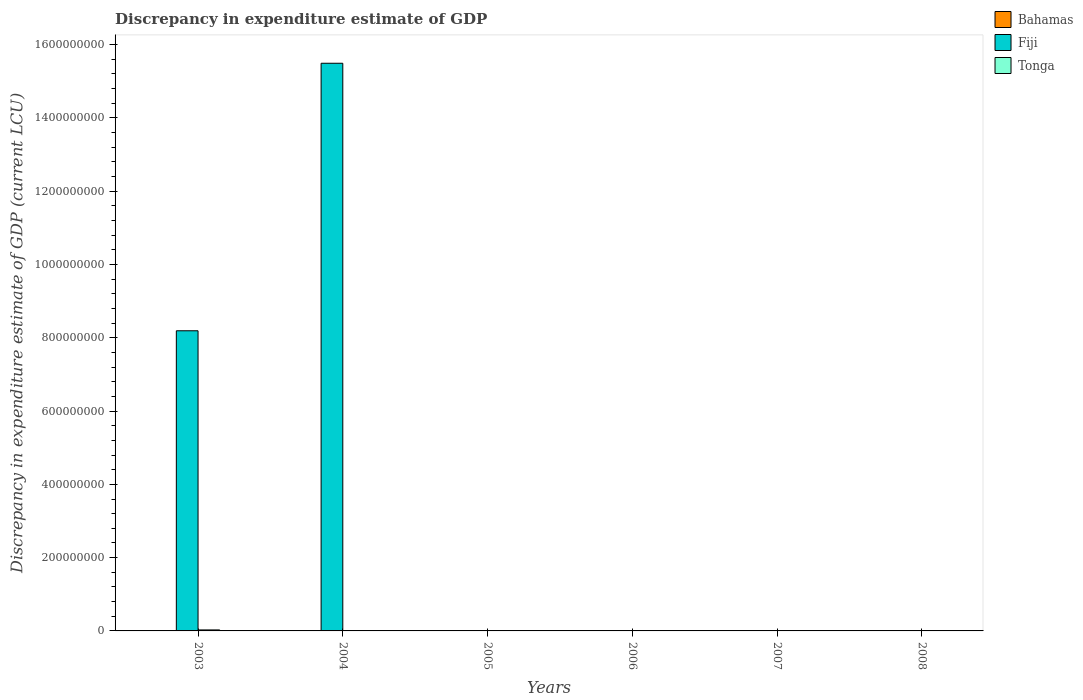How many different coloured bars are there?
Your answer should be very brief. 3. Are the number of bars on each tick of the X-axis equal?
Offer a very short reply. No. How many bars are there on the 2nd tick from the left?
Keep it short and to the point. 2. How many bars are there on the 4th tick from the right?
Your response must be concise. 1. What is the label of the 4th group of bars from the left?
Ensure brevity in your answer.  2006. In how many cases, is the number of bars for a given year not equal to the number of legend labels?
Offer a terse response. 5. What is the discrepancy in expenditure estimate of GDP in Bahamas in 2004?
Your answer should be very brief. 3000. Across all years, what is the maximum discrepancy in expenditure estimate of GDP in Bahamas?
Make the answer very short. 1.20e+04. Across all years, what is the minimum discrepancy in expenditure estimate of GDP in Tonga?
Offer a very short reply. 0. In which year was the discrepancy in expenditure estimate of GDP in Fiji maximum?
Your answer should be compact. 2004. What is the total discrepancy in expenditure estimate of GDP in Bahamas in the graph?
Keep it short and to the point. 3.00e+04. What is the difference between the discrepancy in expenditure estimate of GDP in Bahamas in 2004 and that in 2005?
Give a very brief answer. -9000. What is the difference between the discrepancy in expenditure estimate of GDP in Tonga in 2005 and the discrepancy in expenditure estimate of GDP in Fiji in 2004?
Keep it short and to the point. -1.55e+09. What is the average discrepancy in expenditure estimate of GDP in Bahamas per year?
Provide a succinct answer. 5000. What is the ratio of the discrepancy in expenditure estimate of GDP in Bahamas in 2003 to that in 2006?
Ensure brevity in your answer.  0.87. What is the difference between the highest and the second highest discrepancy in expenditure estimate of GDP in Bahamas?
Offer a very short reply. 4000. What is the difference between the highest and the lowest discrepancy in expenditure estimate of GDP in Fiji?
Offer a terse response. 1.55e+09. In how many years, is the discrepancy in expenditure estimate of GDP in Fiji greater than the average discrepancy in expenditure estimate of GDP in Fiji taken over all years?
Make the answer very short. 2. Is it the case that in every year, the sum of the discrepancy in expenditure estimate of GDP in Bahamas and discrepancy in expenditure estimate of GDP in Fiji is greater than the discrepancy in expenditure estimate of GDP in Tonga?
Keep it short and to the point. No. How many years are there in the graph?
Make the answer very short. 6. What is the difference between two consecutive major ticks on the Y-axis?
Offer a terse response. 2.00e+08. Does the graph contain grids?
Your answer should be compact. No. How are the legend labels stacked?
Offer a terse response. Vertical. What is the title of the graph?
Offer a terse response. Discrepancy in expenditure estimate of GDP. Does "Kenya" appear as one of the legend labels in the graph?
Offer a very short reply. No. What is the label or title of the X-axis?
Offer a very short reply. Years. What is the label or title of the Y-axis?
Your response must be concise. Discrepancy in expenditure estimate of GDP (current LCU). What is the Discrepancy in expenditure estimate of GDP (current LCU) in Bahamas in 2003?
Keep it short and to the point. 7000. What is the Discrepancy in expenditure estimate of GDP (current LCU) in Fiji in 2003?
Your response must be concise. 8.19e+08. What is the Discrepancy in expenditure estimate of GDP (current LCU) in Tonga in 2003?
Make the answer very short. 2.73e+06. What is the Discrepancy in expenditure estimate of GDP (current LCU) of Bahamas in 2004?
Your response must be concise. 3000. What is the Discrepancy in expenditure estimate of GDP (current LCU) of Fiji in 2004?
Provide a succinct answer. 1.55e+09. What is the Discrepancy in expenditure estimate of GDP (current LCU) of Bahamas in 2005?
Your response must be concise. 1.20e+04. What is the Discrepancy in expenditure estimate of GDP (current LCU) of Fiji in 2005?
Provide a succinct answer. 0. What is the Discrepancy in expenditure estimate of GDP (current LCU) in Tonga in 2005?
Keep it short and to the point. 0. What is the Discrepancy in expenditure estimate of GDP (current LCU) in Bahamas in 2006?
Ensure brevity in your answer.  8000. What is the Discrepancy in expenditure estimate of GDP (current LCU) in Tonga in 2007?
Offer a terse response. 0. What is the Discrepancy in expenditure estimate of GDP (current LCU) of Fiji in 2008?
Ensure brevity in your answer.  0. What is the Discrepancy in expenditure estimate of GDP (current LCU) in Tonga in 2008?
Your response must be concise. 0. Across all years, what is the maximum Discrepancy in expenditure estimate of GDP (current LCU) in Bahamas?
Keep it short and to the point. 1.20e+04. Across all years, what is the maximum Discrepancy in expenditure estimate of GDP (current LCU) of Fiji?
Ensure brevity in your answer.  1.55e+09. Across all years, what is the maximum Discrepancy in expenditure estimate of GDP (current LCU) in Tonga?
Make the answer very short. 2.73e+06. Across all years, what is the minimum Discrepancy in expenditure estimate of GDP (current LCU) in Bahamas?
Your response must be concise. 0. Across all years, what is the minimum Discrepancy in expenditure estimate of GDP (current LCU) of Fiji?
Provide a succinct answer. 0. Across all years, what is the minimum Discrepancy in expenditure estimate of GDP (current LCU) of Tonga?
Give a very brief answer. 0. What is the total Discrepancy in expenditure estimate of GDP (current LCU) of Fiji in the graph?
Offer a terse response. 2.37e+09. What is the total Discrepancy in expenditure estimate of GDP (current LCU) in Tonga in the graph?
Your response must be concise. 2.73e+06. What is the difference between the Discrepancy in expenditure estimate of GDP (current LCU) of Bahamas in 2003 and that in 2004?
Your answer should be compact. 4000. What is the difference between the Discrepancy in expenditure estimate of GDP (current LCU) of Fiji in 2003 and that in 2004?
Provide a succinct answer. -7.30e+08. What is the difference between the Discrepancy in expenditure estimate of GDP (current LCU) in Bahamas in 2003 and that in 2005?
Make the answer very short. -5000. What is the difference between the Discrepancy in expenditure estimate of GDP (current LCU) of Bahamas in 2003 and that in 2006?
Offer a very short reply. -1000. What is the difference between the Discrepancy in expenditure estimate of GDP (current LCU) in Bahamas in 2004 and that in 2005?
Your response must be concise. -9000. What is the difference between the Discrepancy in expenditure estimate of GDP (current LCU) of Bahamas in 2004 and that in 2006?
Your response must be concise. -5000. What is the difference between the Discrepancy in expenditure estimate of GDP (current LCU) of Bahamas in 2005 and that in 2006?
Provide a short and direct response. 4000. What is the difference between the Discrepancy in expenditure estimate of GDP (current LCU) in Bahamas in 2003 and the Discrepancy in expenditure estimate of GDP (current LCU) in Fiji in 2004?
Your answer should be compact. -1.55e+09. What is the average Discrepancy in expenditure estimate of GDP (current LCU) in Bahamas per year?
Give a very brief answer. 5000. What is the average Discrepancy in expenditure estimate of GDP (current LCU) of Fiji per year?
Offer a very short reply. 3.95e+08. What is the average Discrepancy in expenditure estimate of GDP (current LCU) in Tonga per year?
Offer a very short reply. 4.56e+05. In the year 2003, what is the difference between the Discrepancy in expenditure estimate of GDP (current LCU) in Bahamas and Discrepancy in expenditure estimate of GDP (current LCU) in Fiji?
Offer a very short reply. -8.19e+08. In the year 2003, what is the difference between the Discrepancy in expenditure estimate of GDP (current LCU) of Bahamas and Discrepancy in expenditure estimate of GDP (current LCU) of Tonga?
Your answer should be compact. -2.73e+06. In the year 2003, what is the difference between the Discrepancy in expenditure estimate of GDP (current LCU) in Fiji and Discrepancy in expenditure estimate of GDP (current LCU) in Tonga?
Provide a succinct answer. 8.16e+08. In the year 2004, what is the difference between the Discrepancy in expenditure estimate of GDP (current LCU) of Bahamas and Discrepancy in expenditure estimate of GDP (current LCU) of Fiji?
Your answer should be compact. -1.55e+09. What is the ratio of the Discrepancy in expenditure estimate of GDP (current LCU) in Bahamas in 2003 to that in 2004?
Provide a short and direct response. 2.33. What is the ratio of the Discrepancy in expenditure estimate of GDP (current LCU) of Fiji in 2003 to that in 2004?
Provide a succinct answer. 0.53. What is the ratio of the Discrepancy in expenditure estimate of GDP (current LCU) of Bahamas in 2003 to that in 2005?
Keep it short and to the point. 0.58. What is the ratio of the Discrepancy in expenditure estimate of GDP (current LCU) in Bahamas in 2004 to that in 2006?
Ensure brevity in your answer.  0.38. What is the ratio of the Discrepancy in expenditure estimate of GDP (current LCU) of Bahamas in 2005 to that in 2006?
Make the answer very short. 1.5. What is the difference between the highest and the second highest Discrepancy in expenditure estimate of GDP (current LCU) in Bahamas?
Offer a very short reply. 4000. What is the difference between the highest and the lowest Discrepancy in expenditure estimate of GDP (current LCU) of Bahamas?
Make the answer very short. 1.20e+04. What is the difference between the highest and the lowest Discrepancy in expenditure estimate of GDP (current LCU) of Fiji?
Offer a very short reply. 1.55e+09. What is the difference between the highest and the lowest Discrepancy in expenditure estimate of GDP (current LCU) of Tonga?
Make the answer very short. 2.73e+06. 